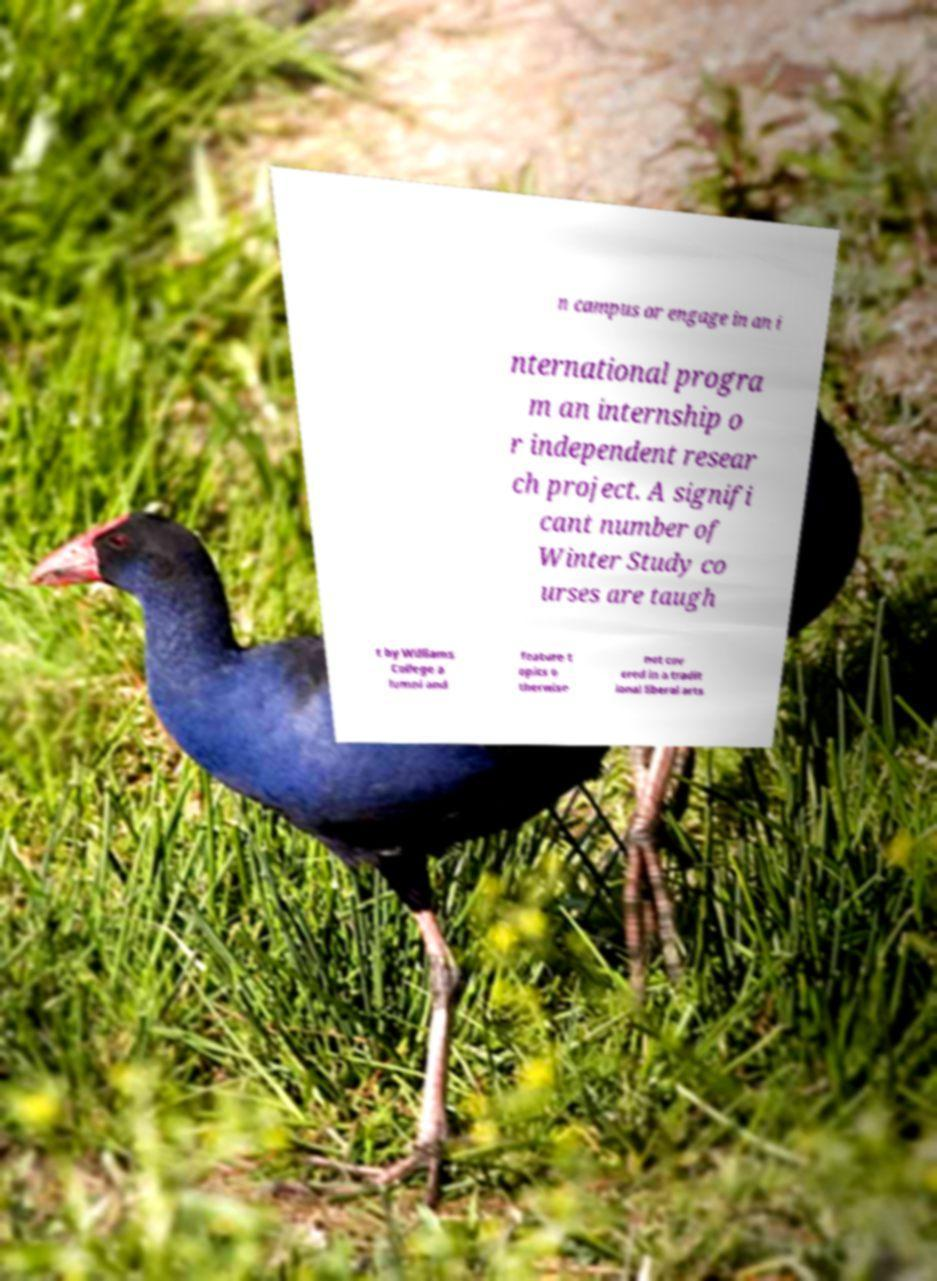Could you assist in decoding the text presented in this image and type it out clearly? n campus or engage in an i nternational progra m an internship o r independent resear ch project. A signifi cant number of Winter Study co urses are taugh t by Williams College a lumni and feature t opics o therwise not cov ered in a tradit ional liberal arts 